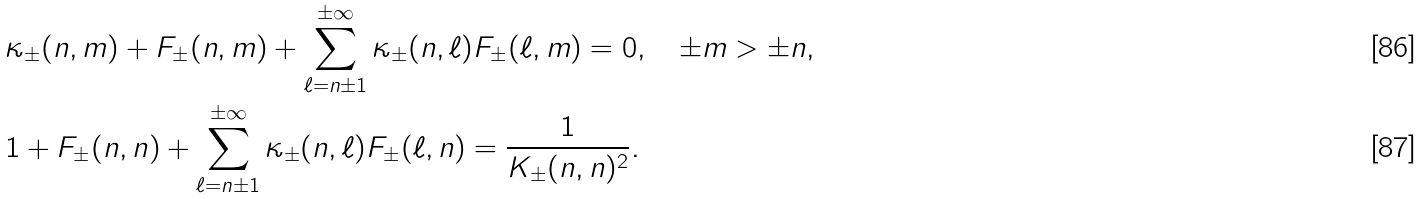Convert formula to latex. <formula><loc_0><loc_0><loc_500><loc_500>& \kappa _ { \pm } ( n , m ) + F _ { \pm } ( n , m ) + \sum _ { \ell = n \pm 1 } ^ { \pm \infty } \kappa _ { \pm } ( n , \ell ) F _ { \pm } ( \ell , m ) = 0 , \quad \pm m > \pm n , \\ & 1 + F _ { \pm } ( n , n ) + \sum _ { \ell = n \pm 1 } ^ { \pm \infty } \kappa _ { \pm } ( n , \ell ) F _ { \pm } ( \ell , n ) = \frac { 1 } { K _ { \pm } ( n , n ) ^ { 2 } } .</formula> 